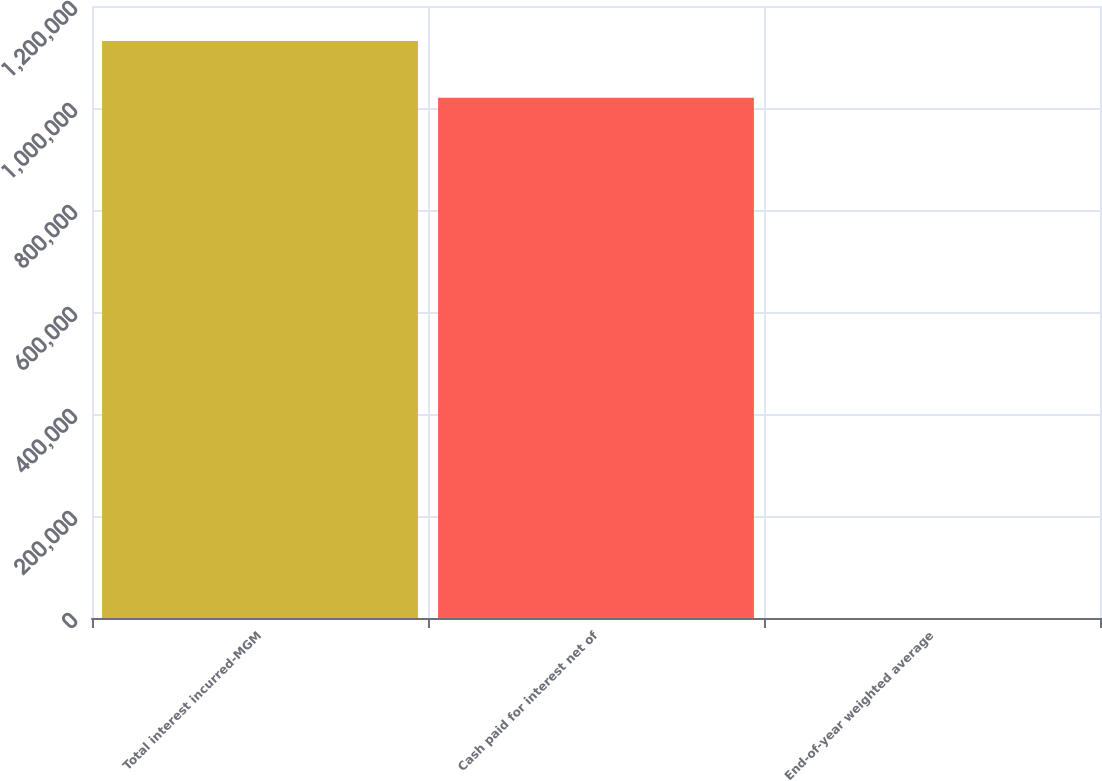<chart> <loc_0><loc_0><loc_500><loc_500><bar_chart><fcel>Total interest incurred-MGM<fcel>Cash paid for interest net of<fcel>End-of-year weighted average<nl><fcel>1.1314e+06<fcel>1.02004e+06<fcel>8<nl></chart> 